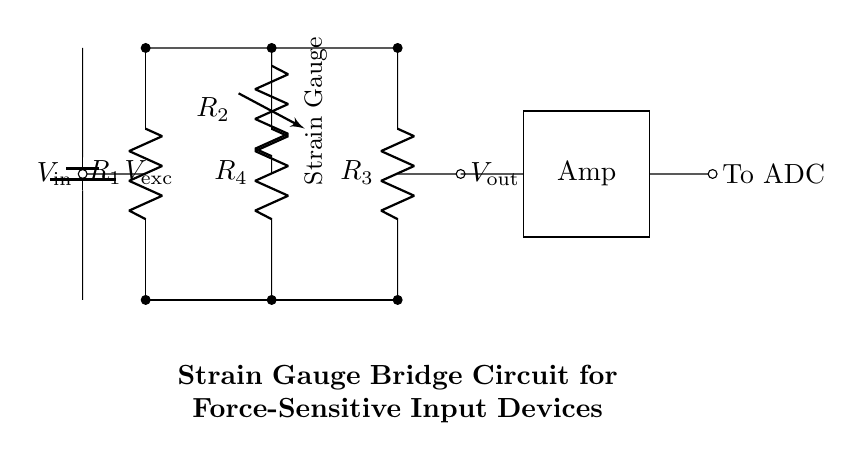What type of circuit is this? This circuit represents a strain gauge bridge circuit, which is used to measure force or strain by monitoring the changes in resistance of a strain gauge within a bridge configuration.
Answer: strain gauge bridge What is the function of R2 in this circuit? R2 serves as the strain gauge, which changes its resistance based on the amount of strain applied to it, thereby affecting the output voltage of the bridge circuit.
Answer: strain gauge How many resistors are present in the bridge? There are four resistors in the bridge configuration: R1, R2, R3, and R4, each playing a role in creating a balanced bridge for precise measurements.
Answer: four What does Vexc represent in this circuit? Vexc indicates the excitation voltage, which powers the circuit and is necessary for the operation of the strain gauge and the bridge configuration.
Answer: excitation voltage What is the output of the amplifier connected to? The output of the amplifier is connected to an Analog-to-Digital Converter (ADC), which digitizes the analog signal for further processing.
Answer: ADC How is the input voltage defined in this circuit? The input voltage, denoted as Vin, is the potential difference between the top and bottom connections of the left side of the bridge, and it is crucial for determining the bridge's balance and output.
Answer: voltage difference What does the variable resistor represent in this setup? The variable resistor in this setup (R2) represents the strain gauge that changes resistance in response to mechanical strain, directly influencing the output voltage across the bridge.
Answer: strain gauge 